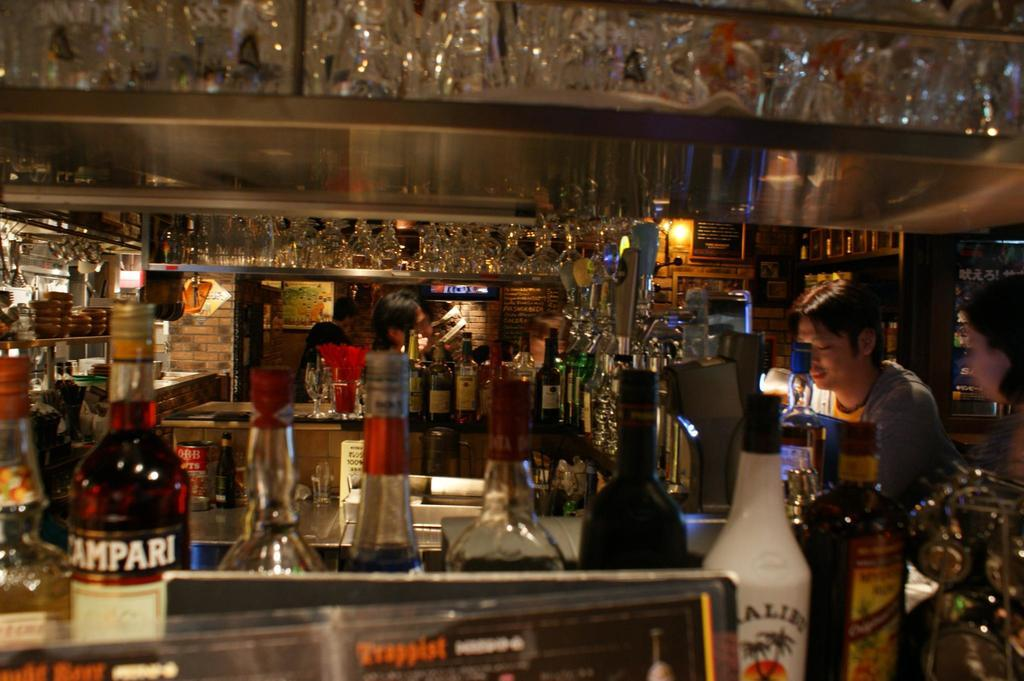How many people can be seen in the image? There are two people on the right side of the image and two people in the middle of the image, making a total of four people. What is the room filled with? The room is filled with wine bottles. Can you describe the lighting in the image? There is a light on the wall. What type of profit can be seen in the image? There is no mention of profit in the image; it features people and wine bottles in a room. Are there any sticks visible in the image? There are no sticks present in the image. 